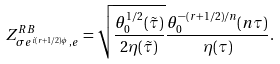<formula> <loc_0><loc_0><loc_500><loc_500>Z _ { \sigma e ^ { i ( r + 1 / 2 ) \phi } , e } ^ { R B } = \sqrt { \frac { \theta _ { 0 } ^ { 1 / 2 } ( \tilde { \tau } ) } { 2 \eta ( \tilde { \tau } ) } } \frac { \theta ^ { - ( r + 1 / 2 ) / n } _ { 0 } ( n \tau ) } { \eta ( \tau ) } .</formula> 